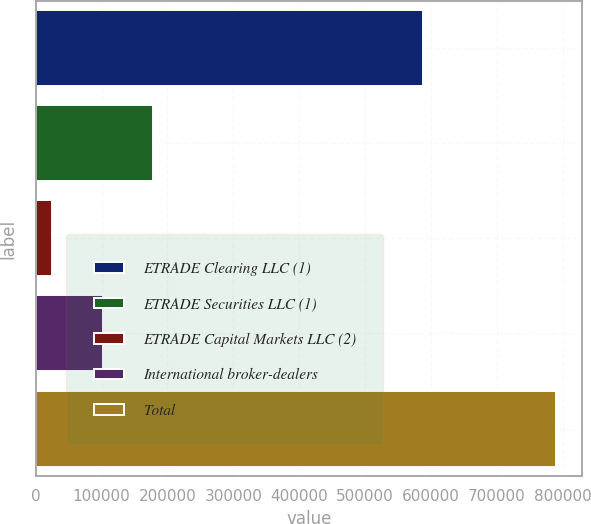<chart> <loc_0><loc_0><loc_500><loc_500><bar_chart><fcel>ETRADE Clearing LLC (1)<fcel>ETRADE Securities LLC (1)<fcel>ETRADE Capital Markets LLC (2)<fcel>International broker-dealers<fcel>Total<nl><fcel>587819<fcel>178001<fcel>24921<fcel>101461<fcel>790320<nl></chart> 